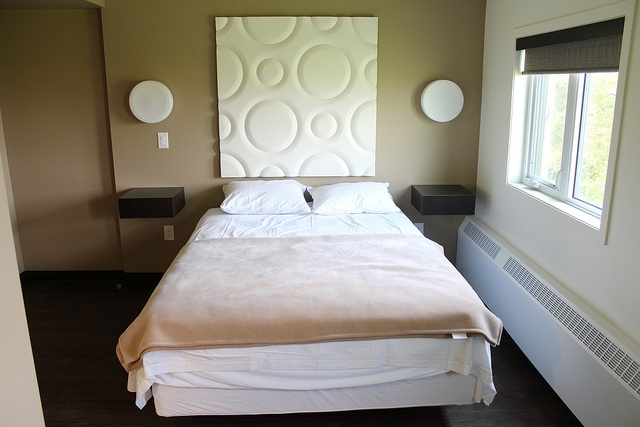Describe the objects in this image and their specific colors. I can see a bed in black, lightgray, darkgray, and gray tones in this image. 